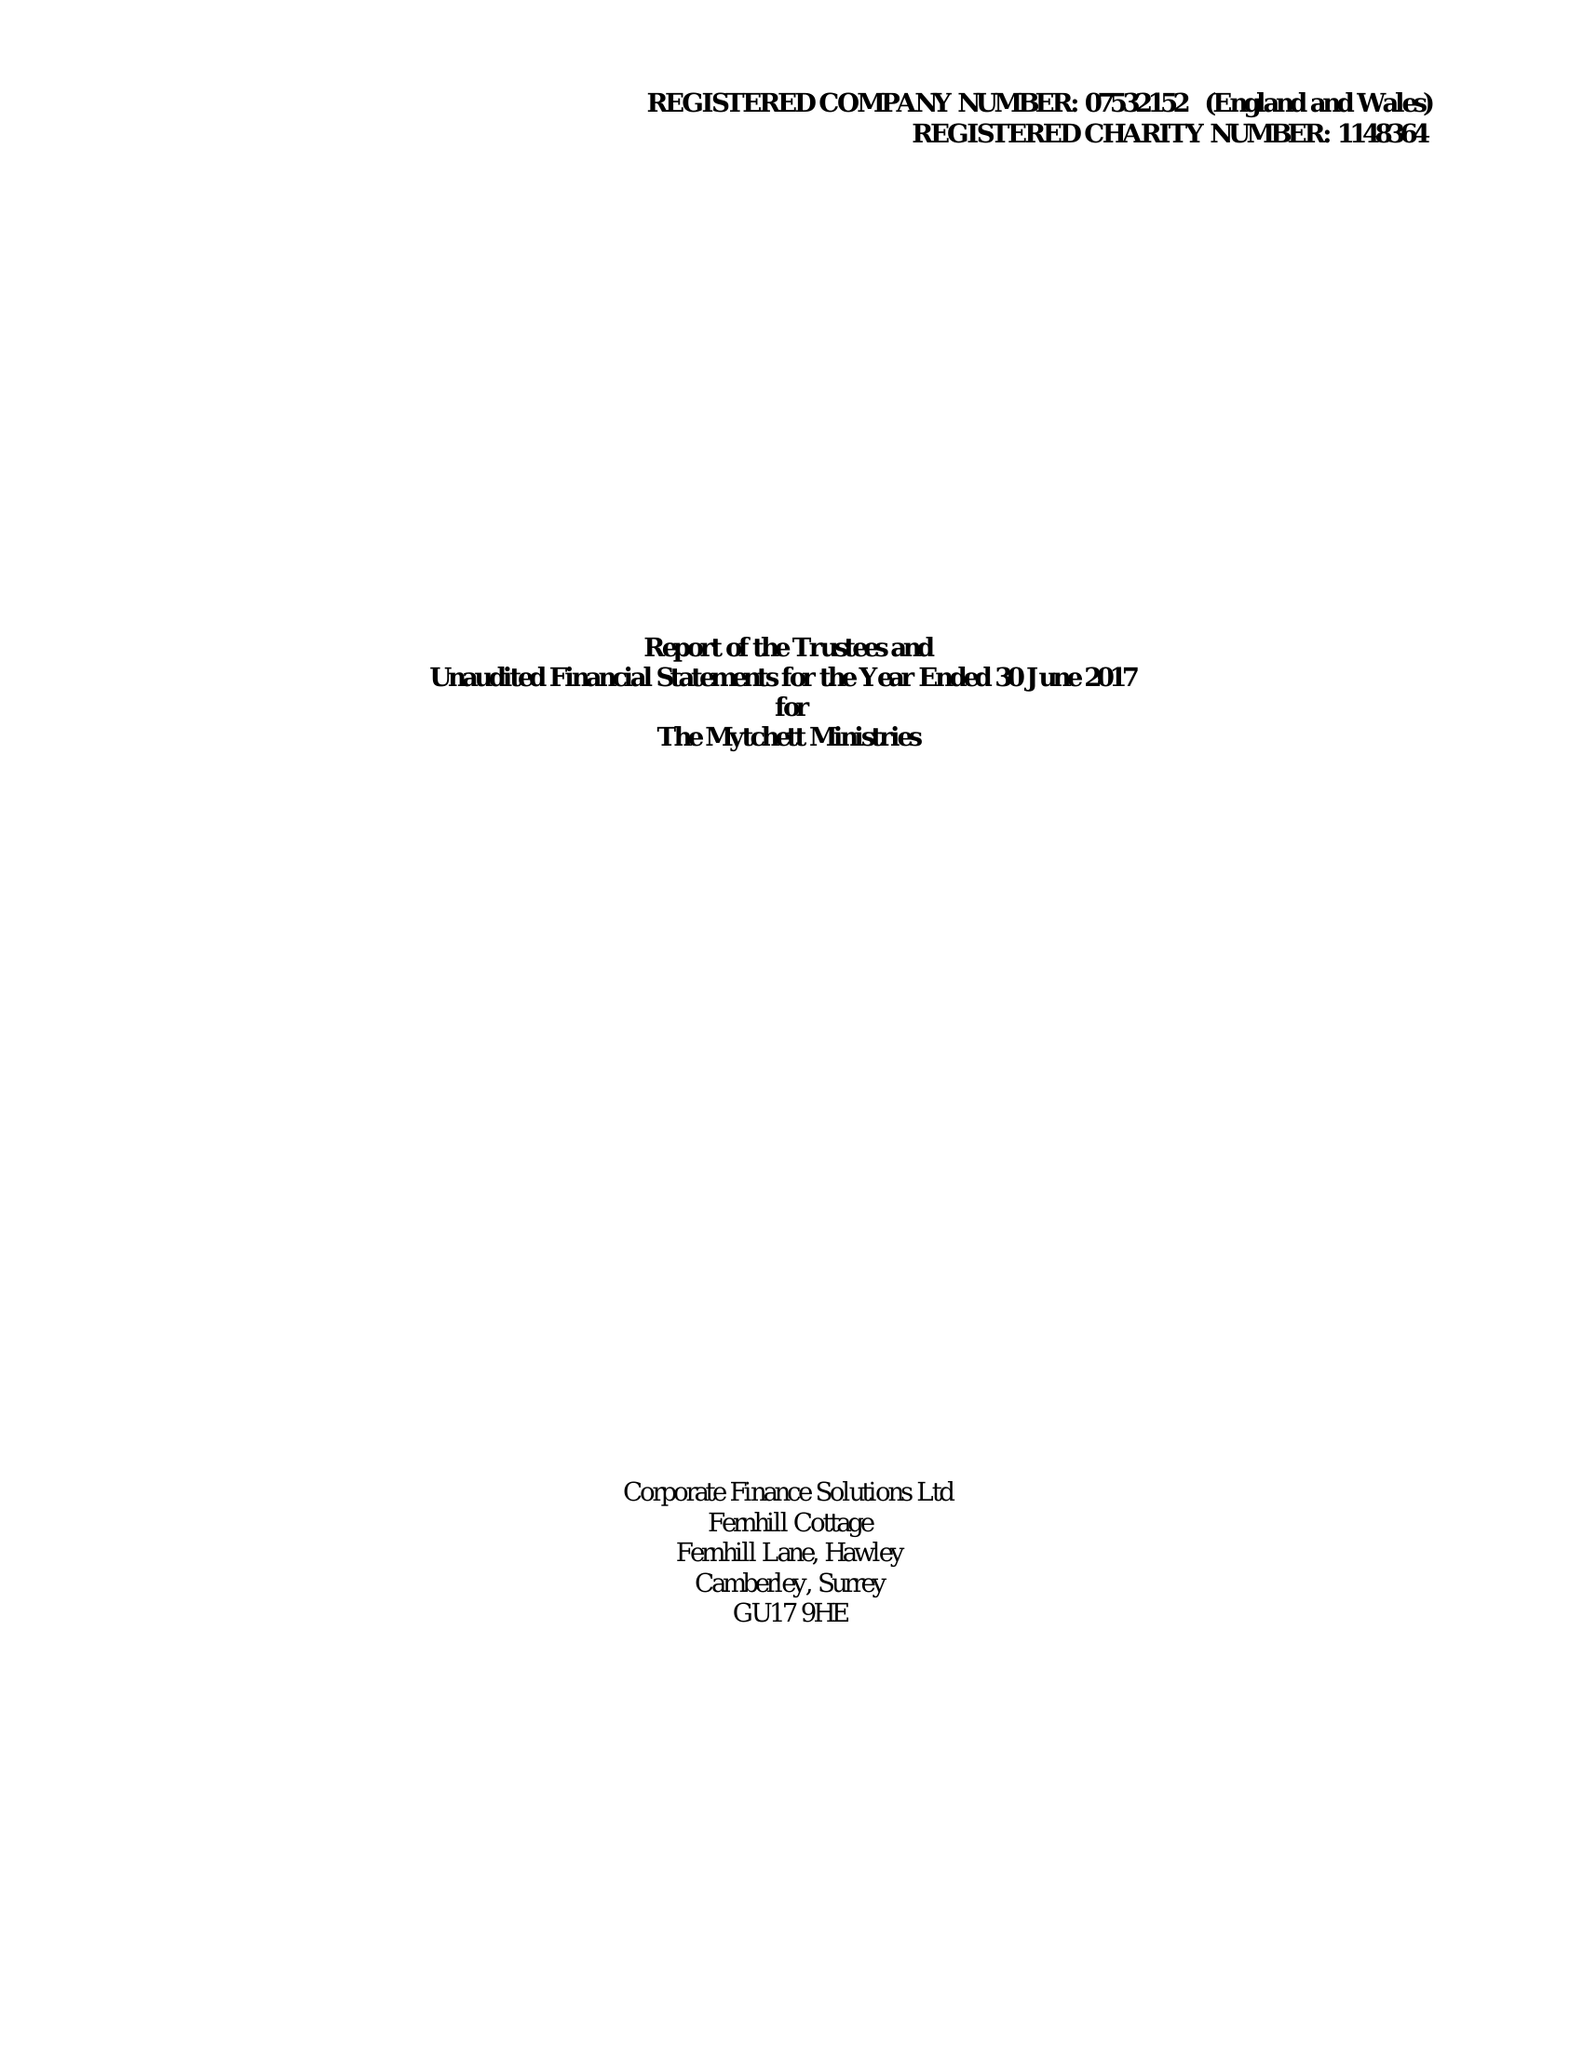What is the value for the charity_name?
Answer the question using a single word or phrase. The Mytchett Ministries 